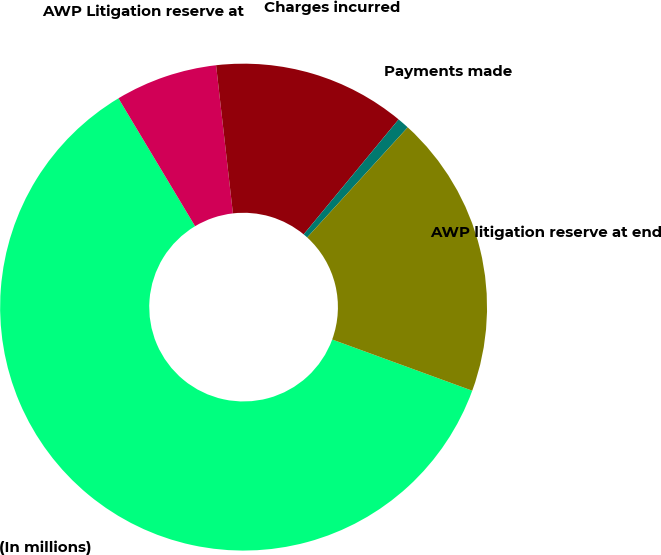<chart> <loc_0><loc_0><loc_500><loc_500><pie_chart><fcel>(In millions)<fcel>AWP Litigation reserve at<fcel>Charges incurred<fcel>Payments made<fcel>AWP litigation reserve at end<nl><fcel>60.83%<fcel>6.79%<fcel>12.79%<fcel>0.79%<fcel>18.8%<nl></chart> 